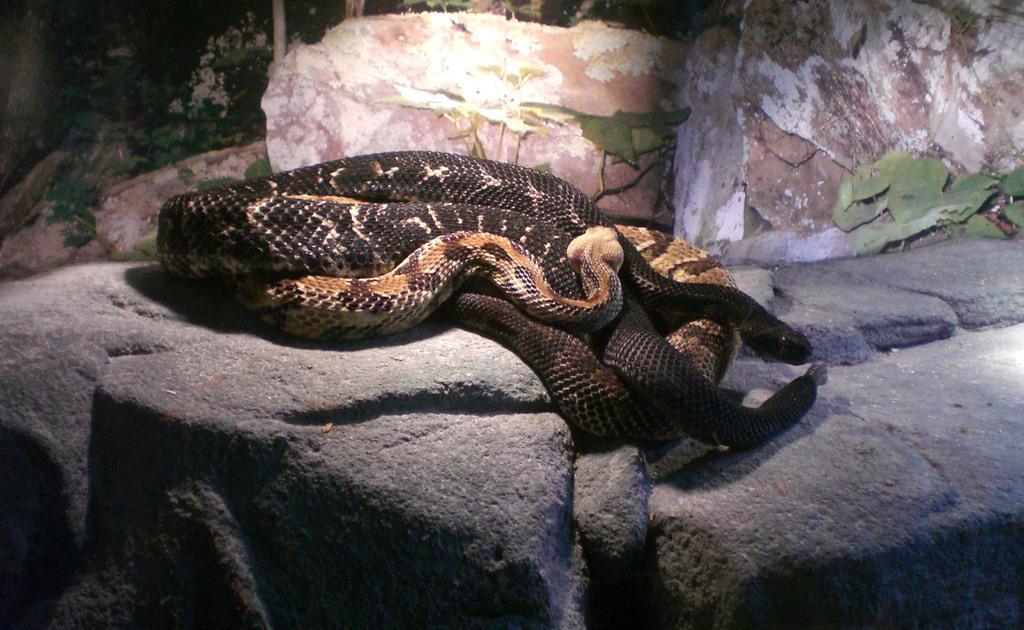Describe this image in one or two sentences. In the image there are two different snakes laying on a rock. 